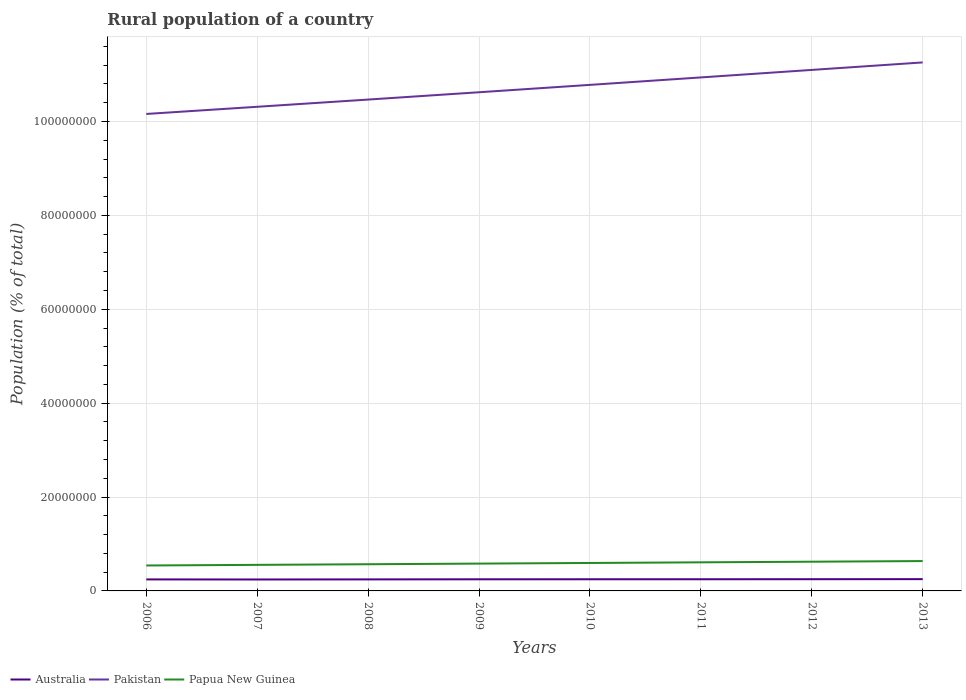Across all years, what is the maximum rural population in Pakistan?
Provide a succinct answer. 1.02e+08. What is the total rural population in Papua New Guinea in the graph?
Your answer should be compact. -1.35e+05. What is the difference between the highest and the second highest rural population in Pakistan?
Provide a succinct answer. 1.10e+07. How many lines are there?
Your answer should be very brief. 3. Are the values on the major ticks of Y-axis written in scientific E-notation?
Ensure brevity in your answer.  No. Does the graph contain any zero values?
Your answer should be very brief. No. Where does the legend appear in the graph?
Your answer should be very brief. Bottom left. How many legend labels are there?
Provide a short and direct response. 3. What is the title of the graph?
Keep it short and to the point. Rural population of a country. What is the label or title of the X-axis?
Ensure brevity in your answer.  Years. What is the label or title of the Y-axis?
Make the answer very short. Population (% of total). What is the Population (% of total) of Australia in 2006?
Provide a succinct answer. 2.45e+06. What is the Population (% of total) in Pakistan in 2006?
Keep it short and to the point. 1.02e+08. What is the Population (% of total) in Papua New Guinea in 2006?
Offer a terse response. 5.42e+06. What is the Population (% of total) of Australia in 2007?
Ensure brevity in your answer.  2.44e+06. What is the Population (% of total) in Pakistan in 2007?
Your answer should be very brief. 1.03e+08. What is the Population (% of total) in Papua New Guinea in 2007?
Your answer should be very brief. 5.55e+06. What is the Population (% of total) of Australia in 2008?
Offer a very short reply. 2.46e+06. What is the Population (% of total) in Pakistan in 2008?
Your response must be concise. 1.05e+08. What is the Population (% of total) in Papua New Guinea in 2008?
Your response must be concise. 5.69e+06. What is the Population (% of total) in Australia in 2009?
Ensure brevity in your answer.  2.48e+06. What is the Population (% of total) of Pakistan in 2009?
Provide a succinct answer. 1.06e+08. What is the Population (% of total) in Papua New Guinea in 2009?
Provide a short and direct response. 5.82e+06. What is the Population (% of total) of Australia in 2010?
Ensure brevity in your answer.  2.48e+06. What is the Population (% of total) of Pakistan in 2010?
Ensure brevity in your answer.  1.08e+08. What is the Population (% of total) of Papua New Guinea in 2010?
Offer a very short reply. 5.96e+06. What is the Population (% of total) of Australia in 2011?
Give a very brief answer. 2.49e+06. What is the Population (% of total) of Pakistan in 2011?
Provide a succinct answer. 1.09e+08. What is the Population (% of total) in Papua New Guinea in 2011?
Your answer should be very brief. 6.09e+06. What is the Population (% of total) of Australia in 2012?
Offer a very short reply. 2.50e+06. What is the Population (% of total) in Pakistan in 2012?
Provide a short and direct response. 1.11e+08. What is the Population (% of total) of Papua New Guinea in 2012?
Offer a very short reply. 6.23e+06. What is the Population (% of total) in Australia in 2013?
Your response must be concise. 2.51e+06. What is the Population (% of total) in Pakistan in 2013?
Your answer should be compact. 1.13e+08. What is the Population (% of total) in Papua New Guinea in 2013?
Offer a terse response. 6.36e+06. Across all years, what is the maximum Population (% of total) in Australia?
Give a very brief answer. 2.51e+06. Across all years, what is the maximum Population (% of total) of Pakistan?
Your answer should be very brief. 1.13e+08. Across all years, what is the maximum Population (% of total) in Papua New Guinea?
Provide a short and direct response. 6.36e+06. Across all years, what is the minimum Population (% of total) of Australia?
Provide a short and direct response. 2.44e+06. Across all years, what is the minimum Population (% of total) in Pakistan?
Ensure brevity in your answer.  1.02e+08. Across all years, what is the minimum Population (% of total) in Papua New Guinea?
Offer a very short reply. 5.42e+06. What is the total Population (% of total) of Australia in the graph?
Make the answer very short. 1.98e+07. What is the total Population (% of total) in Pakistan in the graph?
Provide a succinct answer. 8.56e+08. What is the total Population (% of total) in Papua New Guinea in the graph?
Provide a short and direct response. 4.71e+07. What is the difference between the Population (% of total) in Australia in 2006 and that in 2007?
Give a very brief answer. 1.55e+04. What is the difference between the Population (% of total) of Pakistan in 2006 and that in 2007?
Provide a succinct answer. -1.53e+06. What is the difference between the Population (% of total) in Papua New Guinea in 2006 and that in 2007?
Make the answer very short. -1.33e+05. What is the difference between the Population (% of total) in Australia in 2006 and that in 2008?
Make the answer very short. -2644. What is the difference between the Population (% of total) of Pakistan in 2006 and that in 2008?
Ensure brevity in your answer.  -3.07e+06. What is the difference between the Population (% of total) in Papua New Guinea in 2006 and that in 2008?
Provide a succinct answer. -2.67e+05. What is the difference between the Population (% of total) of Australia in 2006 and that in 2009?
Offer a very short reply. -2.23e+04. What is the difference between the Population (% of total) in Pakistan in 2006 and that in 2009?
Ensure brevity in your answer.  -4.62e+06. What is the difference between the Population (% of total) in Papua New Guinea in 2006 and that in 2009?
Your answer should be compact. -4.01e+05. What is the difference between the Population (% of total) in Australia in 2006 and that in 2010?
Keep it short and to the point. -2.96e+04. What is the difference between the Population (% of total) of Pakistan in 2006 and that in 2010?
Provide a succinct answer. -6.20e+06. What is the difference between the Population (% of total) in Papua New Guinea in 2006 and that in 2010?
Ensure brevity in your answer.  -5.36e+05. What is the difference between the Population (% of total) of Australia in 2006 and that in 2011?
Provide a succinct answer. -3.26e+04. What is the difference between the Population (% of total) in Pakistan in 2006 and that in 2011?
Provide a succinct answer. -7.78e+06. What is the difference between the Population (% of total) in Papua New Guinea in 2006 and that in 2011?
Keep it short and to the point. -6.71e+05. What is the difference between the Population (% of total) in Australia in 2006 and that in 2012?
Your response must be concise. -4.40e+04. What is the difference between the Population (% of total) of Pakistan in 2006 and that in 2012?
Your response must be concise. -9.38e+06. What is the difference between the Population (% of total) in Papua New Guinea in 2006 and that in 2012?
Your answer should be very brief. -8.06e+05. What is the difference between the Population (% of total) of Australia in 2006 and that in 2013?
Your response must be concise. -5.58e+04. What is the difference between the Population (% of total) in Pakistan in 2006 and that in 2013?
Keep it short and to the point. -1.10e+07. What is the difference between the Population (% of total) of Papua New Guinea in 2006 and that in 2013?
Provide a succinct answer. -9.41e+05. What is the difference between the Population (% of total) in Australia in 2007 and that in 2008?
Give a very brief answer. -1.81e+04. What is the difference between the Population (% of total) of Pakistan in 2007 and that in 2008?
Provide a short and direct response. -1.54e+06. What is the difference between the Population (% of total) of Papua New Guinea in 2007 and that in 2008?
Ensure brevity in your answer.  -1.34e+05. What is the difference between the Population (% of total) of Australia in 2007 and that in 2009?
Provide a succinct answer. -3.78e+04. What is the difference between the Population (% of total) in Pakistan in 2007 and that in 2009?
Offer a terse response. -3.10e+06. What is the difference between the Population (% of total) of Papua New Guinea in 2007 and that in 2009?
Make the answer very short. -2.69e+05. What is the difference between the Population (% of total) in Australia in 2007 and that in 2010?
Your answer should be compact. -4.51e+04. What is the difference between the Population (% of total) of Pakistan in 2007 and that in 2010?
Your response must be concise. -4.67e+06. What is the difference between the Population (% of total) in Papua New Guinea in 2007 and that in 2010?
Offer a very short reply. -4.04e+05. What is the difference between the Population (% of total) in Australia in 2007 and that in 2011?
Your answer should be compact. -4.81e+04. What is the difference between the Population (% of total) in Pakistan in 2007 and that in 2011?
Your answer should be very brief. -6.26e+06. What is the difference between the Population (% of total) in Papua New Guinea in 2007 and that in 2011?
Keep it short and to the point. -5.39e+05. What is the difference between the Population (% of total) of Australia in 2007 and that in 2012?
Your response must be concise. -5.95e+04. What is the difference between the Population (% of total) in Pakistan in 2007 and that in 2012?
Your answer should be very brief. -7.86e+06. What is the difference between the Population (% of total) of Papua New Guinea in 2007 and that in 2012?
Offer a terse response. -6.74e+05. What is the difference between the Population (% of total) of Australia in 2007 and that in 2013?
Make the answer very short. -7.12e+04. What is the difference between the Population (% of total) in Pakistan in 2007 and that in 2013?
Provide a short and direct response. -9.45e+06. What is the difference between the Population (% of total) in Papua New Guinea in 2007 and that in 2013?
Make the answer very short. -8.08e+05. What is the difference between the Population (% of total) of Australia in 2008 and that in 2009?
Provide a succinct answer. -1.97e+04. What is the difference between the Population (% of total) in Pakistan in 2008 and that in 2009?
Give a very brief answer. -1.56e+06. What is the difference between the Population (% of total) of Papua New Guinea in 2008 and that in 2009?
Your answer should be very brief. -1.35e+05. What is the difference between the Population (% of total) of Australia in 2008 and that in 2010?
Your response must be concise. -2.70e+04. What is the difference between the Population (% of total) of Pakistan in 2008 and that in 2010?
Your answer should be very brief. -3.13e+06. What is the difference between the Population (% of total) in Papua New Guinea in 2008 and that in 2010?
Ensure brevity in your answer.  -2.70e+05. What is the difference between the Population (% of total) in Australia in 2008 and that in 2011?
Ensure brevity in your answer.  -3.00e+04. What is the difference between the Population (% of total) in Pakistan in 2008 and that in 2011?
Make the answer very short. -4.72e+06. What is the difference between the Population (% of total) in Papua New Guinea in 2008 and that in 2011?
Your answer should be compact. -4.05e+05. What is the difference between the Population (% of total) of Australia in 2008 and that in 2012?
Give a very brief answer. -4.14e+04. What is the difference between the Population (% of total) of Pakistan in 2008 and that in 2012?
Provide a succinct answer. -6.32e+06. What is the difference between the Population (% of total) in Papua New Guinea in 2008 and that in 2012?
Your answer should be compact. -5.40e+05. What is the difference between the Population (% of total) of Australia in 2008 and that in 2013?
Your answer should be very brief. -5.31e+04. What is the difference between the Population (% of total) of Pakistan in 2008 and that in 2013?
Keep it short and to the point. -7.91e+06. What is the difference between the Population (% of total) in Papua New Guinea in 2008 and that in 2013?
Your answer should be very brief. -6.74e+05. What is the difference between the Population (% of total) of Australia in 2009 and that in 2010?
Offer a terse response. -7294. What is the difference between the Population (% of total) of Pakistan in 2009 and that in 2010?
Give a very brief answer. -1.57e+06. What is the difference between the Population (% of total) in Papua New Guinea in 2009 and that in 2010?
Provide a succinct answer. -1.35e+05. What is the difference between the Population (% of total) of Australia in 2009 and that in 2011?
Your answer should be very brief. -1.03e+04. What is the difference between the Population (% of total) of Pakistan in 2009 and that in 2011?
Give a very brief answer. -3.16e+06. What is the difference between the Population (% of total) in Papua New Guinea in 2009 and that in 2011?
Offer a terse response. -2.70e+05. What is the difference between the Population (% of total) of Australia in 2009 and that in 2012?
Make the answer very short. -2.17e+04. What is the difference between the Population (% of total) of Pakistan in 2009 and that in 2012?
Offer a terse response. -4.76e+06. What is the difference between the Population (% of total) in Papua New Guinea in 2009 and that in 2012?
Your response must be concise. -4.05e+05. What is the difference between the Population (% of total) of Australia in 2009 and that in 2013?
Ensure brevity in your answer.  -3.34e+04. What is the difference between the Population (% of total) of Pakistan in 2009 and that in 2013?
Ensure brevity in your answer.  -6.35e+06. What is the difference between the Population (% of total) in Papua New Guinea in 2009 and that in 2013?
Give a very brief answer. -5.39e+05. What is the difference between the Population (% of total) of Australia in 2010 and that in 2011?
Provide a succinct answer. -3011. What is the difference between the Population (% of total) in Pakistan in 2010 and that in 2011?
Make the answer very short. -1.59e+06. What is the difference between the Population (% of total) of Papua New Guinea in 2010 and that in 2011?
Your answer should be compact. -1.35e+05. What is the difference between the Population (% of total) in Australia in 2010 and that in 2012?
Make the answer very short. -1.44e+04. What is the difference between the Population (% of total) of Pakistan in 2010 and that in 2012?
Your answer should be compact. -3.19e+06. What is the difference between the Population (% of total) of Papua New Guinea in 2010 and that in 2012?
Your response must be concise. -2.70e+05. What is the difference between the Population (% of total) of Australia in 2010 and that in 2013?
Give a very brief answer. -2.61e+04. What is the difference between the Population (% of total) in Pakistan in 2010 and that in 2013?
Make the answer very short. -4.78e+06. What is the difference between the Population (% of total) in Papua New Guinea in 2010 and that in 2013?
Keep it short and to the point. -4.04e+05. What is the difference between the Population (% of total) of Australia in 2011 and that in 2012?
Offer a terse response. -1.14e+04. What is the difference between the Population (% of total) in Pakistan in 2011 and that in 2012?
Ensure brevity in your answer.  -1.60e+06. What is the difference between the Population (% of total) in Papua New Guinea in 2011 and that in 2012?
Your answer should be compact. -1.35e+05. What is the difference between the Population (% of total) in Australia in 2011 and that in 2013?
Keep it short and to the point. -2.31e+04. What is the difference between the Population (% of total) of Pakistan in 2011 and that in 2013?
Offer a very short reply. -3.19e+06. What is the difference between the Population (% of total) in Papua New Guinea in 2011 and that in 2013?
Offer a terse response. -2.69e+05. What is the difference between the Population (% of total) of Australia in 2012 and that in 2013?
Your response must be concise. -1.18e+04. What is the difference between the Population (% of total) in Pakistan in 2012 and that in 2013?
Give a very brief answer. -1.60e+06. What is the difference between the Population (% of total) in Papua New Guinea in 2012 and that in 2013?
Keep it short and to the point. -1.34e+05. What is the difference between the Population (% of total) of Australia in 2006 and the Population (% of total) of Pakistan in 2007?
Make the answer very short. -1.01e+08. What is the difference between the Population (% of total) in Australia in 2006 and the Population (% of total) in Papua New Guinea in 2007?
Make the answer very short. -3.10e+06. What is the difference between the Population (% of total) in Pakistan in 2006 and the Population (% of total) in Papua New Guinea in 2007?
Offer a very short reply. 9.61e+07. What is the difference between the Population (% of total) of Australia in 2006 and the Population (% of total) of Pakistan in 2008?
Your response must be concise. -1.02e+08. What is the difference between the Population (% of total) of Australia in 2006 and the Population (% of total) of Papua New Guinea in 2008?
Provide a short and direct response. -3.23e+06. What is the difference between the Population (% of total) in Pakistan in 2006 and the Population (% of total) in Papua New Guinea in 2008?
Ensure brevity in your answer.  9.59e+07. What is the difference between the Population (% of total) in Australia in 2006 and the Population (% of total) in Pakistan in 2009?
Your answer should be compact. -1.04e+08. What is the difference between the Population (% of total) of Australia in 2006 and the Population (% of total) of Papua New Guinea in 2009?
Make the answer very short. -3.37e+06. What is the difference between the Population (% of total) in Pakistan in 2006 and the Population (% of total) in Papua New Guinea in 2009?
Make the answer very short. 9.58e+07. What is the difference between the Population (% of total) of Australia in 2006 and the Population (% of total) of Pakistan in 2010?
Your response must be concise. -1.05e+08. What is the difference between the Population (% of total) of Australia in 2006 and the Population (% of total) of Papua New Guinea in 2010?
Offer a very short reply. -3.50e+06. What is the difference between the Population (% of total) of Pakistan in 2006 and the Population (% of total) of Papua New Guinea in 2010?
Your answer should be very brief. 9.57e+07. What is the difference between the Population (% of total) of Australia in 2006 and the Population (% of total) of Pakistan in 2011?
Your response must be concise. -1.07e+08. What is the difference between the Population (% of total) of Australia in 2006 and the Population (% of total) of Papua New Guinea in 2011?
Make the answer very short. -3.64e+06. What is the difference between the Population (% of total) of Pakistan in 2006 and the Population (% of total) of Papua New Guinea in 2011?
Offer a very short reply. 9.55e+07. What is the difference between the Population (% of total) of Australia in 2006 and the Population (% of total) of Pakistan in 2012?
Provide a short and direct response. -1.09e+08. What is the difference between the Population (% of total) in Australia in 2006 and the Population (% of total) in Papua New Guinea in 2012?
Offer a very short reply. -3.77e+06. What is the difference between the Population (% of total) of Pakistan in 2006 and the Population (% of total) of Papua New Guinea in 2012?
Ensure brevity in your answer.  9.54e+07. What is the difference between the Population (% of total) of Australia in 2006 and the Population (% of total) of Pakistan in 2013?
Make the answer very short. -1.10e+08. What is the difference between the Population (% of total) of Australia in 2006 and the Population (% of total) of Papua New Guinea in 2013?
Make the answer very short. -3.91e+06. What is the difference between the Population (% of total) of Pakistan in 2006 and the Population (% of total) of Papua New Guinea in 2013?
Keep it short and to the point. 9.53e+07. What is the difference between the Population (% of total) in Australia in 2007 and the Population (% of total) in Pakistan in 2008?
Offer a very short reply. -1.02e+08. What is the difference between the Population (% of total) in Australia in 2007 and the Population (% of total) in Papua New Guinea in 2008?
Offer a very short reply. -3.25e+06. What is the difference between the Population (% of total) in Pakistan in 2007 and the Population (% of total) in Papua New Guinea in 2008?
Your answer should be very brief. 9.75e+07. What is the difference between the Population (% of total) of Australia in 2007 and the Population (% of total) of Pakistan in 2009?
Provide a short and direct response. -1.04e+08. What is the difference between the Population (% of total) of Australia in 2007 and the Population (% of total) of Papua New Guinea in 2009?
Your answer should be compact. -3.38e+06. What is the difference between the Population (% of total) of Pakistan in 2007 and the Population (% of total) of Papua New Guinea in 2009?
Keep it short and to the point. 9.73e+07. What is the difference between the Population (% of total) of Australia in 2007 and the Population (% of total) of Pakistan in 2010?
Your answer should be very brief. -1.05e+08. What is the difference between the Population (% of total) of Australia in 2007 and the Population (% of total) of Papua New Guinea in 2010?
Make the answer very short. -3.52e+06. What is the difference between the Population (% of total) of Pakistan in 2007 and the Population (% of total) of Papua New Guinea in 2010?
Ensure brevity in your answer.  9.72e+07. What is the difference between the Population (% of total) in Australia in 2007 and the Population (% of total) in Pakistan in 2011?
Offer a terse response. -1.07e+08. What is the difference between the Population (% of total) in Australia in 2007 and the Population (% of total) in Papua New Guinea in 2011?
Provide a succinct answer. -3.65e+06. What is the difference between the Population (% of total) of Pakistan in 2007 and the Population (% of total) of Papua New Guinea in 2011?
Provide a short and direct response. 9.71e+07. What is the difference between the Population (% of total) of Australia in 2007 and the Population (% of total) of Pakistan in 2012?
Offer a very short reply. -1.09e+08. What is the difference between the Population (% of total) of Australia in 2007 and the Population (% of total) of Papua New Guinea in 2012?
Your answer should be very brief. -3.79e+06. What is the difference between the Population (% of total) of Pakistan in 2007 and the Population (% of total) of Papua New Guinea in 2012?
Your answer should be very brief. 9.69e+07. What is the difference between the Population (% of total) in Australia in 2007 and the Population (% of total) in Pakistan in 2013?
Provide a succinct answer. -1.10e+08. What is the difference between the Population (% of total) of Australia in 2007 and the Population (% of total) of Papua New Guinea in 2013?
Keep it short and to the point. -3.92e+06. What is the difference between the Population (% of total) of Pakistan in 2007 and the Population (% of total) of Papua New Guinea in 2013?
Provide a succinct answer. 9.68e+07. What is the difference between the Population (% of total) of Australia in 2008 and the Population (% of total) of Pakistan in 2009?
Give a very brief answer. -1.04e+08. What is the difference between the Population (% of total) of Australia in 2008 and the Population (% of total) of Papua New Guinea in 2009?
Give a very brief answer. -3.37e+06. What is the difference between the Population (% of total) of Pakistan in 2008 and the Population (% of total) of Papua New Guinea in 2009?
Provide a short and direct response. 9.89e+07. What is the difference between the Population (% of total) in Australia in 2008 and the Population (% of total) in Pakistan in 2010?
Your response must be concise. -1.05e+08. What is the difference between the Population (% of total) of Australia in 2008 and the Population (% of total) of Papua New Guinea in 2010?
Make the answer very short. -3.50e+06. What is the difference between the Population (% of total) in Pakistan in 2008 and the Population (% of total) in Papua New Guinea in 2010?
Your response must be concise. 9.87e+07. What is the difference between the Population (% of total) of Australia in 2008 and the Population (% of total) of Pakistan in 2011?
Keep it short and to the point. -1.07e+08. What is the difference between the Population (% of total) in Australia in 2008 and the Population (% of total) in Papua New Guinea in 2011?
Give a very brief answer. -3.64e+06. What is the difference between the Population (% of total) of Pakistan in 2008 and the Population (% of total) of Papua New Guinea in 2011?
Your answer should be compact. 9.86e+07. What is the difference between the Population (% of total) of Australia in 2008 and the Population (% of total) of Pakistan in 2012?
Provide a short and direct response. -1.09e+08. What is the difference between the Population (% of total) in Australia in 2008 and the Population (% of total) in Papua New Guinea in 2012?
Keep it short and to the point. -3.77e+06. What is the difference between the Population (% of total) in Pakistan in 2008 and the Population (% of total) in Papua New Guinea in 2012?
Provide a short and direct response. 9.85e+07. What is the difference between the Population (% of total) in Australia in 2008 and the Population (% of total) in Pakistan in 2013?
Offer a very short reply. -1.10e+08. What is the difference between the Population (% of total) of Australia in 2008 and the Population (% of total) of Papua New Guinea in 2013?
Keep it short and to the point. -3.91e+06. What is the difference between the Population (% of total) of Pakistan in 2008 and the Population (% of total) of Papua New Guinea in 2013?
Your answer should be very brief. 9.83e+07. What is the difference between the Population (% of total) in Australia in 2009 and the Population (% of total) in Pakistan in 2010?
Provide a succinct answer. -1.05e+08. What is the difference between the Population (% of total) of Australia in 2009 and the Population (% of total) of Papua New Guinea in 2010?
Keep it short and to the point. -3.48e+06. What is the difference between the Population (% of total) in Pakistan in 2009 and the Population (% of total) in Papua New Guinea in 2010?
Provide a short and direct response. 1.00e+08. What is the difference between the Population (% of total) in Australia in 2009 and the Population (% of total) in Pakistan in 2011?
Provide a succinct answer. -1.07e+08. What is the difference between the Population (% of total) of Australia in 2009 and the Population (% of total) of Papua New Guinea in 2011?
Your answer should be very brief. -3.62e+06. What is the difference between the Population (% of total) of Pakistan in 2009 and the Population (% of total) of Papua New Guinea in 2011?
Make the answer very short. 1.00e+08. What is the difference between the Population (% of total) of Australia in 2009 and the Population (% of total) of Pakistan in 2012?
Your answer should be compact. -1.09e+08. What is the difference between the Population (% of total) of Australia in 2009 and the Population (% of total) of Papua New Guinea in 2012?
Offer a very short reply. -3.75e+06. What is the difference between the Population (% of total) in Pakistan in 2009 and the Population (% of total) in Papua New Guinea in 2012?
Ensure brevity in your answer.  1.00e+08. What is the difference between the Population (% of total) in Australia in 2009 and the Population (% of total) in Pakistan in 2013?
Provide a succinct answer. -1.10e+08. What is the difference between the Population (% of total) in Australia in 2009 and the Population (% of total) in Papua New Guinea in 2013?
Provide a short and direct response. -3.89e+06. What is the difference between the Population (% of total) in Pakistan in 2009 and the Population (% of total) in Papua New Guinea in 2013?
Keep it short and to the point. 9.99e+07. What is the difference between the Population (% of total) in Australia in 2010 and the Population (% of total) in Pakistan in 2011?
Your answer should be compact. -1.07e+08. What is the difference between the Population (% of total) in Australia in 2010 and the Population (% of total) in Papua New Guinea in 2011?
Offer a terse response. -3.61e+06. What is the difference between the Population (% of total) in Pakistan in 2010 and the Population (% of total) in Papua New Guinea in 2011?
Keep it short and to the point. 1.02e+08. What is the difference between the Population (% of total) in Australia in 2010 and the Population (% of total) in Pakistan in 2012?
Offer a very short reply. -1.09e+08. What is the difference between the Population (% of total) in Australia in 2010 and the Population (% of total) in Papua New Guinea in 2012?
Keep it short and to the point. -3.74e+06. What is the difference between the Population (% of total) of Pakistan in 2010 and the Population (% of total) of Papua New Guinea in 2012?
Your answer should be very brief. 1.02e+08. What is the difference between the Population (% of total) of Australia in 2010 and the Population (% of total) of Pakistan in 2013?
Provide a succinct answer. -1.10e+08. What is the difference between the Population (% of total) of Australia in 2010 and the Population (% of total) of Papua New Guinea in 2013?
Your response must be concise. -3.88e+06. What is the difference between the Population (% of total) in Pakistan in 2010 and the Population (% of total) in Papua New Guinea in 2013?
Your response must be concise. 1.01e+08. What is the difference between the Population (% of total) of Australia in 2011 and the Population (% of total) of Pakistan in 2012?
Provide a short and direct response. -1.09e+08. What is the difference between the Population (% of total) of Australia in 2011 and the Population (% of total) of Papua New Guinea in 2012?
Provide a short and direct response. -3.74e+06. What is the difference between the Population (% of total) of Pakistan in 2011 and the Population (% of total) of Papua New Guinea in 2012?
Make the answer very short. 1.03e+08. What is the difference between the Population (% of total) in Australia in 2011 and the Population (% of total) in Pakistan in 2013?
Make the answer very short. -1.10e+08. What is the difference between the Population (% of total) in Australia in 2011 and the Population (% of total) in Papua New Guinea in 2013?
Your response must be concise. -3.88e+06. What is the difference between the Population (% of total) in Pakistan in 2011 and the Population (% of total) in Papua New Guinea in 2013?
Ensure brevity in your answer.  1.03e+08. What is the difference between the Population (% of total) in Australia in 2012 and the Population (% of total) in Pakistan in 2013?
Make the answer very short. -1.10e+08. What is the difference between the Population (% of total) in Australia in 2012 and the Population (% of total) in Papua New Guinea in 2013?
Ensure brevity in your answer.  -3.86e+06. What is the difference between the Population (% of total) in Pakistan in 2012 and the Population (% of total) in Papua New Guinea in 2013?
Provide a succinct answer. 1.05e+08. What is the average Population (% of total) in Australia per year?
Ensure brevity in your answer.  2.47e+06. What is the average Population (% of total) in Pakistan per year?
Provide a succinct answer. 1.07e+08. What is the average Population (% of total) in Papua New Guinea per year?
Make the answer very short. 5.89e+06. In the year 2006, what is the difference between the Population (% of total) of Australia and Population (% of total) of Pakistan?
Ensure brevity in your answer.  -9.92e+07. In the year 2006, what is the difference between the Population (% of total) of Australia and Population (% of total) of Papua New Guinea?
Provide a succinct answer. -2.97e+06. In the year 2006, what is the difference between the Population (% of total) of Pakistan and Population (% of total) of Papua New Guinea?
Give a very brief answer. 9.62e+07. In the year 2007, what is the difference between the Population (% of total) of Australia and Population (% of total) of Pakistan?
Offer a terse response. -1.01e+08. In the year 2007, what is the difference between the Population (% of total) of Australia and Population (% of total) of Papua New Guinea?
Provide a succinct answer. -3.12e+06. In the year 2007, what is the difference between the Population (% of total) of Pakistan and Population (% of total) of Papua New Guinea?
Provide a short and direct response. 9.76e+07. In the year 2008, what is the difference between the Population (% of total) of Australia and Population (% of total) of Pakistan?
Offer a terse response. -1.02e+08. In the year 2008, what is the difference between the Population (% of total) in Australia and Population (% of total) in Papua New Guinea?
Offer a terse response. -3.23e+06. In the year 2008, what is the difference between the Population (% of total) in Pakistan and Population (% of total) in Papua New Guinea?
Your answer should be compact. 9.90e+07. In the year 2009, what is the difference between the Population (% of total) of Australia and Population (% of total) of Pakistan?
Give a very brief answer. -1.04e+08. In the year 2009, what is the difference between the Population (% of total) of Australia and Population (% of total) of Papua New Guinea?
Give a very brief answer. -3.35e+06. In the year 2009, what is the difference between the Population (% of total) in Pakistan and Population (% of total) in Papua New Guinea?
Your answer should be compact. 1.00e+08. In the year 2010, what is the difference between the Population (% of total) in Australia and Population (% of total) in Pakistan?
Provide a short and direct response. -1.05e+08. In the year 2010, what is the difference between the Population (% of total) in Australia and Population (% of total) in Papua New Guinea?
Keep it short and to the point. -3.47e+06. In the year 2010, what is the difference between the Population (% of total) of Pakistan and Population (% of total) of Papua New Guinea?
Give a very brief answer. 1.02e+08. In the year 2011, what is the difference between the Population (% of total) of Australia and Population (% of total) of Pakistan?
Offer a terse response. -1.07e+08. In the year 2011, what is the difference between the Population (% of total) of Australia and Population (% of total) of Papua New Guinea?
Your response must be concise. -3.61e+06. In the year 2011, what is the difference between the Population (% of total) of Pakistan and Population (% of total) of Papua New Guinea?
Your response must be concise. 1.03e+08. In the year 2012, what is the difference between the Population (% of total) of Australia and Population (% of total) of Pakistan?
Provide a short and direct response. -1.09e+08. In the year 2012, what is the difference between the Population (% of total) of Australia and Population (% of total) of Papua New Guinea?
Give a very brief answer. -3.73e+06. In the year 2012, what is the difference between the Population (% of total) in Pakistan and Population (% of total) in Papua New Guinea?
Ensure brevity in your answer.  1.05e+08. In the year 2013, what is the difference between the Population (% of total) of Australia and Population (% of total) of Pakistan?
Your answer should be compact. -1.10e+08. In the year 2013, what is the difference between the Population (% of total) of Australia and Population (% of total) of Papua New Guinea?
Make the answer very short. -3.85e+06. In the year 2013, what is the difference between the Population (% of total) of Pakistan and Population (% of total) of Papua New Guinea?
Your response must be concise. 1.06e+08. What is the ratio of the Population (% of total) in Australia in 2006 to that in 2007?
Your response must be concise. 1.01. What is the ratio of the Population (% of total) of Pakistan in 2006 to that in 2007?
Keep it short and to the point. 0.99. What is the ratio of the Population (% of total) of Papua New Guinea in 2006 to that in 2007?
Your response must be concise. 0.98. What is the ratio of the Population (% of total) of Australia in 2006 to that in 2008?
Ensure brevity in your answer.  1. What is the ratio of the Population (% of total) of Pakistan in 2006 to that in 2008?
Your answer should be compact. 0.97. What is the ratio of the Population (% of total) in Papua New Guinea in 2006 to that in 2008?
Make the answer very short. 0.95. What is the ratio of the Population (% of total) of Australia in 2006 to that in 2009?
Provide a succinct answer. 0.99. What is the ratio of the Population (% of total) of Pakistan in 2006 to that in 2009?
Provide a short and direct response. 0.96. What is the ratio of the Population (% of total) in Papua New Guinea in 2006 to that in 2009?
Offer a terse response. 0.93. What is the ratio of the Population (% of total) of Pakistan in 2006 to that in 2010?
Your answer should be compact. 0.94. What is the ratio of the Population (% of total) in Papua New Guinea in 2006 to that in 2010?
Give a very brief answer. 0.91. What is the ratio of the Population (% of total) of Australia in 2006 to that in 2011?
Offer a terse response. 0.99. What is the ratio of the Population (% of total) of Pakistan in 2006 to that in 2011?
Your answer should be compact. 0.93. What is the ratio of the Population (% of total) in Papua New Guinea in 2006 to that in 2011?
Your answer should be compact. 0.89. What is the ratio of the Population (% of total) of Australia in 2006 to that in 2012?
Keep it short and to the point. 0.98. What is the ratio of the Population (% of total) in Pakistan in 2006 to that in 2012?
Offer a terse response. 0.92. What is the ratio of the Population (% of total) of Papua New Guinea in 2006 to that in 2012?
Give a very brief answer. 0.87. What is the ratio of the Population (% of total) in Australia in 2006 to that in 2013?
Your answer should be compact. 0.98. What is the ratio of the Population (% of total) of Pakistan in 2006 to that in 2013?
Give a very brief answer. 0.9. What is the ratio of the Population (% of total) in Papua New Guinea in 2006 to that in 2013?
Give a very brief answer. 0.85. What is the ratio of the Population (% of total) in Australia in 2007 to that in 2008?
Provide a short and direct response. 0.99. What is the ratio of the Population (% of total) in Papua New Guinea in 2007 to that in 2008?
Ensure brevity in your answer.  0.98. What is the ratio of the Population (% of total) of Australia in 2007 to that in 2009?
Keep it short and to the point. 0.98. What is the ratio of the Population (% of total) of Pakistan in 2007 to that in 2009?
Provide a succinct answer. 0.97. What is the ratio of the Population (% of total) of Papua New Guinea in 2007 to that in 2009?
Your answer should be compact. 0.95. What is the ratio of the Population (% of total) of Australia in 2007 to that in 2010?
Make the answer very short. 0.98. What is the ratio of the Population (% of total) in Pakistan in 2007 to that in 2010?
Your response must be concise. 0.96. What is the ratio of the Population (% of total) in Papua New Guinea in 2007 to that in 2010?
Your answer should be compact. 0.93. What is the ratio of the Population (% of total) of Australia in 2007 to that in 2011?
Keep it short and to the point. 0.98. What is the ratio of the Population (% of total) of Pakistan in 2007 to that in 2011?
Ensure brevity in your answer.  0.94. What is the ratio of the Population (% of total) of Papua New Guinea in 2007 to that in 2011?
Make the answer very short. 0.91. What is the ratio of the Population (% of total) of Australia in 2007 to that in 2012?
Provide a succinct answer. 0.98. What is the ratio of the Population (% of total) in Pakistan in 2007 to that in 2012?
Offer a very short reply. 0.93. What is the ratio of the Population (% of total) of Papua New Guinea in 2007 to that in 2012?
Keep it short and to the point. 0.89. What is the ratio of the Population (% of total) in Australia in 2007 to that in 2013?
Provide a succinct answer. 0.97. What is the ratio of the Population (% of total) in Pakistan in 2007 to that in 2013?
Ensure brevity in your answer.  0.92. What is the ratio of the Population (% of total) of Papua New Guinea in 2007 to that in 2013?
Your answer should be very brief. 0.87. What is the ratio of the Population (% of total) of Australia in 2008 to that in 2009?
Make the answer very short. 0.99. What is the ratio of the Population (% of total) in Papua New Guinea in 2008 to that in 2009?
Give a very brief answer. 0.98. What is the ratio of the Population (% of total) in Pakistan in 2008 to that in 2010?
Your response must be concise. 0.97. What is the ratio of the Population (% of total) of Papua New Guinea in 2008 to that in 2010?
Give a very brief answer. 0.95. What is the ratio of the Population (% of total) in Australia in 2008 to that in 2011?
Keep it short and to the point. 0.99. What is the ratio of the Population (% of total) in Pakistan in 2008 to that in 2011?
Offer a very short reply. 0.96. What is the ratio of the Population (% of total) of Papua New Guinea in 2008 to that in 2011?
Provide a short and direct response. 0.93. What is the ratio of the Population (% of total) in Australia in 2008 to that in 2012?
Your answer should be very brief. 0.98. What is the ratio of the Population (% of total) in Pakistan in 2008 to that in 2012?
Ensure brevity in your answer.  0.94. What is the ratio of the Population (% of total) of Papua New Guinea in 2008 to that in 2012?
Make the answer very short. 0.91. What is the ratio of the Population (% of total) of Australia in 2008 to that in 2013?
Your answer should be compact. 0.98. What is the ratio of the Population (% of total) of Pakistan in 2008 to that in 2013?
Provide a succinct answer. 0.93. What is the ratio of the Population (% of total) in Papua New Guinea in 2008 to that in 2013?
Make the answer very short. 0.89. What is the ratio of the Population (% of total) in Australia in 2009 to that in 2010?
Give a very brief answer. 1. What is the ratio of the Population (% of total) in Pakistan in 2009 to that in 2010?
Offer a terse response. 0.99. What is the ratio of the Population (% of total) of Papua New Guinea in 2009 to that in 2010?
Offer a terse response. 0.98. What is the ratio of the Population (% of total) in Australia in 2009 to that in 2011?
Give a very brief answer. 1. What is the ratio of the Population (% of total) in Pakistan in 2009 to that in 2011?
Provide a succinct answer. 0.97. What is the ratio of the Population (% of total) in Papua New Guinea in 2009 to that in 2011?
Offer a terse response. 0.96. What is the ratio of the Population (% of total) in Australia in 2009 to that in 2012?
Your answer should be very brief. 0.99. What is the ratio of the Population (% of total) of Pakistan in 2009 to that in 2012?
Give a very brief answer. 0.96. What is the ratio of the Population (% of total) in Papua New Guinea in 2009 to that in 2012?
Make the answer very short. 0.94. What is the ratio of the Population (% of total) in Australia in 2009 to that in 2013?
Ensure brevity in your answer.  0.99. What is the ratio of the Population (% of total) in Pakistan in 2009 to that in 2013?
Offer a terse response. 0.94. What is the ratio of the Population (% of total) in Papua New Guinea in 2009 to that in 2013?
Your answer should be very brief. 0.92. What is the ratio of the Population (% of total) in Australia in 2010 to that in 2011?
Your answer should be very brief. 1. What is the ratio of the Population (% of total) in Pakistan in 2010 to that in 2011?
Provide a short and direct response. 0.99. What is the ratio of the Population (% of total) of Papua New Guinea in 2010 to that in 2011?
Keep it short and to the point. 0.98. What is the ratio of the Population (% of total) in Pakistan in 2010 to that in 2012?
Offer a very short reply. 0.97. What is the ratio of the Population (% of total) of Papua New Guinea in 2010 to that in 2012?
Keep it short and to the point. 0.96. What is the ratio of the Population (% of total) in Australia in 2010 to that in 2013?
Offer a very short reply. 0.99. What is the ratio of the Population (% of total) of Pakistan in 2010 to that in 2013?
Ensure brevity in your answer.  0.96. What is the ratio of the Population (% of total) in Papua New Guinea in 2010 to that in 2013?
Your answer should be compact. 0.94. What is the ratio of the Population (% of total) in Australia in 2011 to that in 2012?
Provide a short and direct response. 1. What is the ratio of the Population (% of total) of Pakistan in 2011 to that in 2012?
Give a very brief answer. 0.99. What is the ratio of the Population (% of total) in Papua New Guinea in 2011 to that in 2012?
Keep it short and to the point. 0.98. What is the ratio of the Population (% of total) of Pakistan in 2011 to that in 2013?
Offer a very short reply. 0.97. What is the ratio of the Population (% of total) in Papua New Guinea in 2011 to that in 2013?
Provide a succinct answer. 0.96. What is the ratio of the Population (% of total) of Pakistan in 2012 to that in 2013?
Make the answer very short. 0.99. What is the ratio of the Population (% of total) of Papua New Guinea in 2012 to that in 2013?
Your response must be concise. 0.98. What is the difference between the highest and the second highest Population (% of total) in Australia?
Ensure brevity in your answer.  1.18e+04. What is the difference between the highest and the second highest Population (% of total) of Pakistan?
Provide a succinct answer. 1.60e+06. What is the difference between the highest and the second highest Population (% of total) in Papua New Guinea?
Your response must be concise. 1.34e+05. What is the difference between the highest and the lowest Population (% of total) of Australia?
Provide a succinct answer. 7.12e+04. What is the difference between the highest and the lowest Population (% of total) in Pakistan?
Offer a terse response. 1.10e+07. What is the difference between the highest and the lowest Population (% of total) in Papua New Guinea?
Provide a short and direct response. 9.41e+05. 